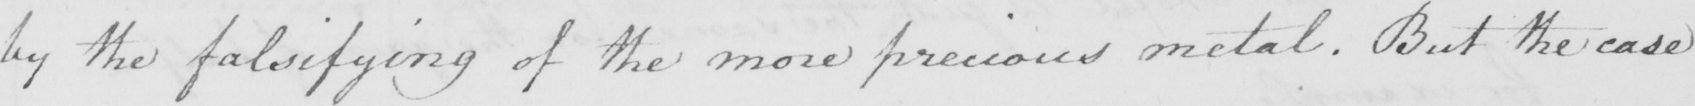Transcribe the text shown in this historical manuscript line. by the falsifying of the more precious metal. But the case 